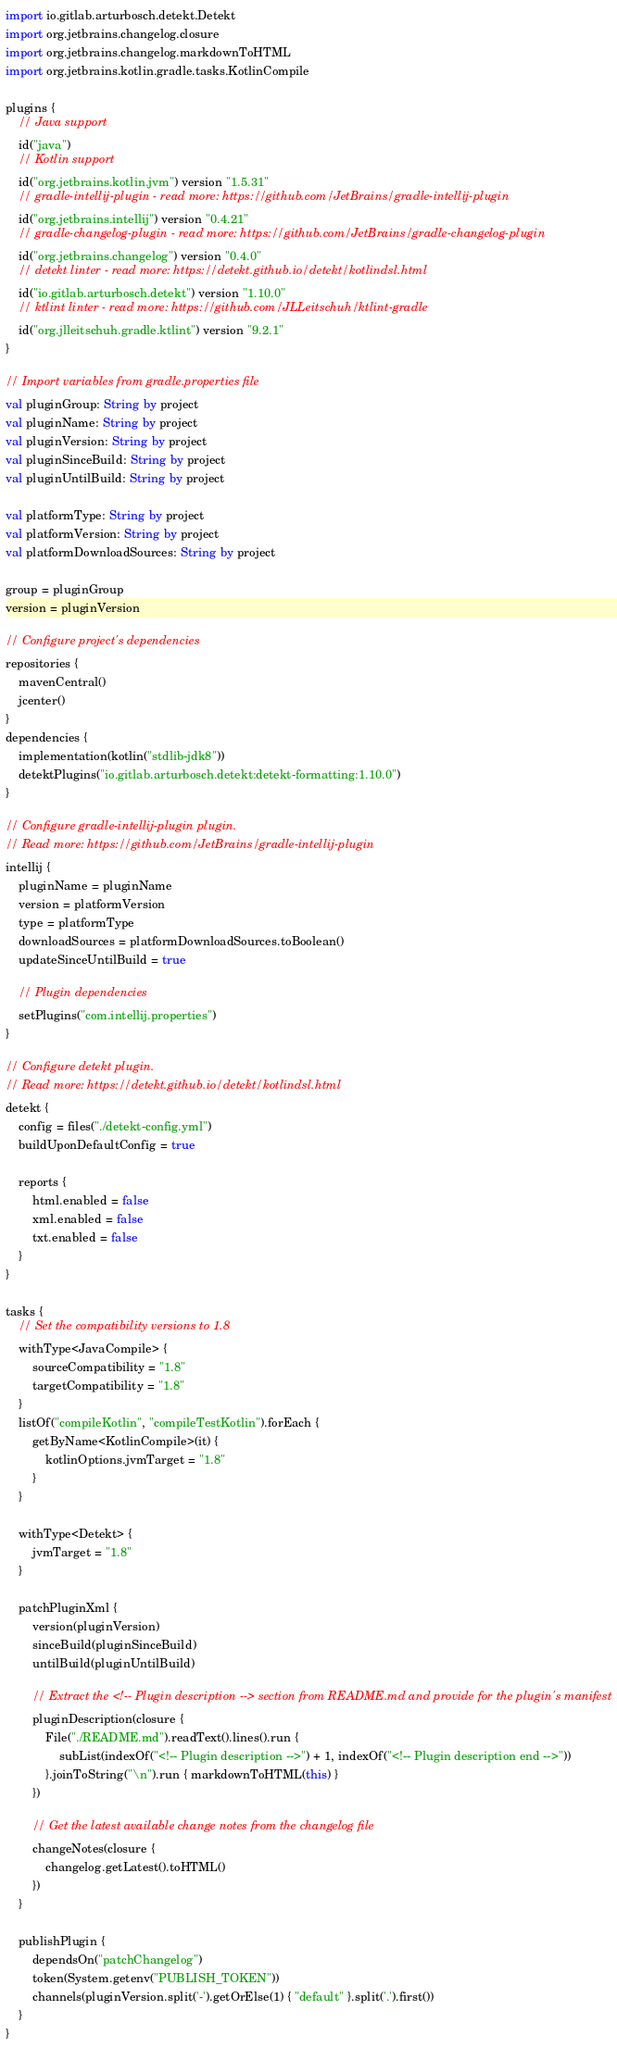<code> <loc_0><loc_0><loc_500><loc_500><_Kotlin_>import io.gitlab.arturbosch.detekt.Detekt
import org.jetbrains.changelog.closure
import org.jetbrains.changelog.markdownToHTML
import org.jetbrains.kotlin.gradle.tasks.KotlinCompile

plugins {
    // Java support
    id("java")
    // Kotlin support
    id("org.jetbrains.kotlin.jvm") version "1.5.31"
    // gradle-intellij-plugin - read more: https://github.com/JetBrains/gradle-intellij-plugin
    id("org.jetbrains.intellij") version "0.4.21"
    // gradle-changelog-plugin - read more: https://github.com/JetBrains/gradle-changelog-plugin
    id("org.jetbrains.changelog") version "0.4.0"
    // detekt linter - read more: https://detekt.github.io/detekt/kotlindsl.html
    id("io.gitlab.arturbosch.detekt") version "1.10.0"
    // ktlint linter - read more: https://github.com/JLLeitschuh/ktlint-gradle
    id("org.jlleitschuh.gradle.ktlint") version "9.2.1"
}

// Import variables from gradle.properties file
val pluginGroup: String by project
val pluginName: String by project
val pluginVersion: String by project
val pluginSinceBuild: String by project
val pluginUntilBuild: String by project

val platformType: String by project
val platformVersion: String by project
val platformDownloadSources: String by project

group = pluginGroup
version = pluginVersion

// Configure project's dependencies
repositories {
    mavenCentral()
    jcenter()
}
dependencies {
    implementation(kotlin("stdlib-jdk8"))
    detektPlugins("io.gitlab.arturbosch.detekt:detekt-formatting:1.10.0")
}

// Configure gradle-intellij-plugin plugin.
// Read more: https://github.com/JetBrains/gradle-intellij-plugin
intellij {
    pluginName = pluginName
    version = platformVersion
    type = platformType
    downloadSources = platformDownloadSources.toBoolean()
    updateSinceUntilBuild = true

    // Plugin dependencies
    setPlugins("com.intellij.properties")
}

// Configure detekt plugin.
// Read more: https://detekt.github.io/detekt/kotlindsl.html
detekt {
    config = files("./detekt-config.yml")
    buildUponDefaultConfig = true

    reports {
        html.enabled = false
        xml.enabled = false
        txt.enabled = false
    }
}

tasks {
    // Set the compatibility versions to 1.8
    withType<JavaCompile> {
        sourceCompatibility = "1.8"
        targetCompatibility = "1.8"
    }
    listOf("compileKotlin", "compileTestKotlin").forEach {
        getByName<KotlinCompile>(it) {
            kotlinOptions.jvmTarget = "1.8"
        }
    }

    withType<Detekt> {
        jvmTarget = "1.8"
    }

    patchPluginXml {
        version(pluginVersion)
        sinceBuild(pluginSinceBuild)
        untilBuild(pluginUntilBuild)

        // Extract the <!-- Plugin description --> section from README.md and provide for the plugin's manifest
        pluginDescription(closure {
            File("./README.md").readText().lines().run {
                subList(indexOf("<!-- Plugin description -->") + 1, indexOf("<!-- Plugin description end -->"))
            }.joinToString("\n").run { markdownToHTML(this) }
        })

        // Get the latest available change notes from the changelog file
        changeNotes(closure {
            changelog.getLatest().toHTML()
        })
    }

    publishPlugin {
        dependsOn("patchChangelog")
        token(System.getenv("PUBLISH_TOKEN"))
        channels(pluginVersion.split('-').getOrElse(1) { "default" }.split('.').first())
    }
}
</code> 